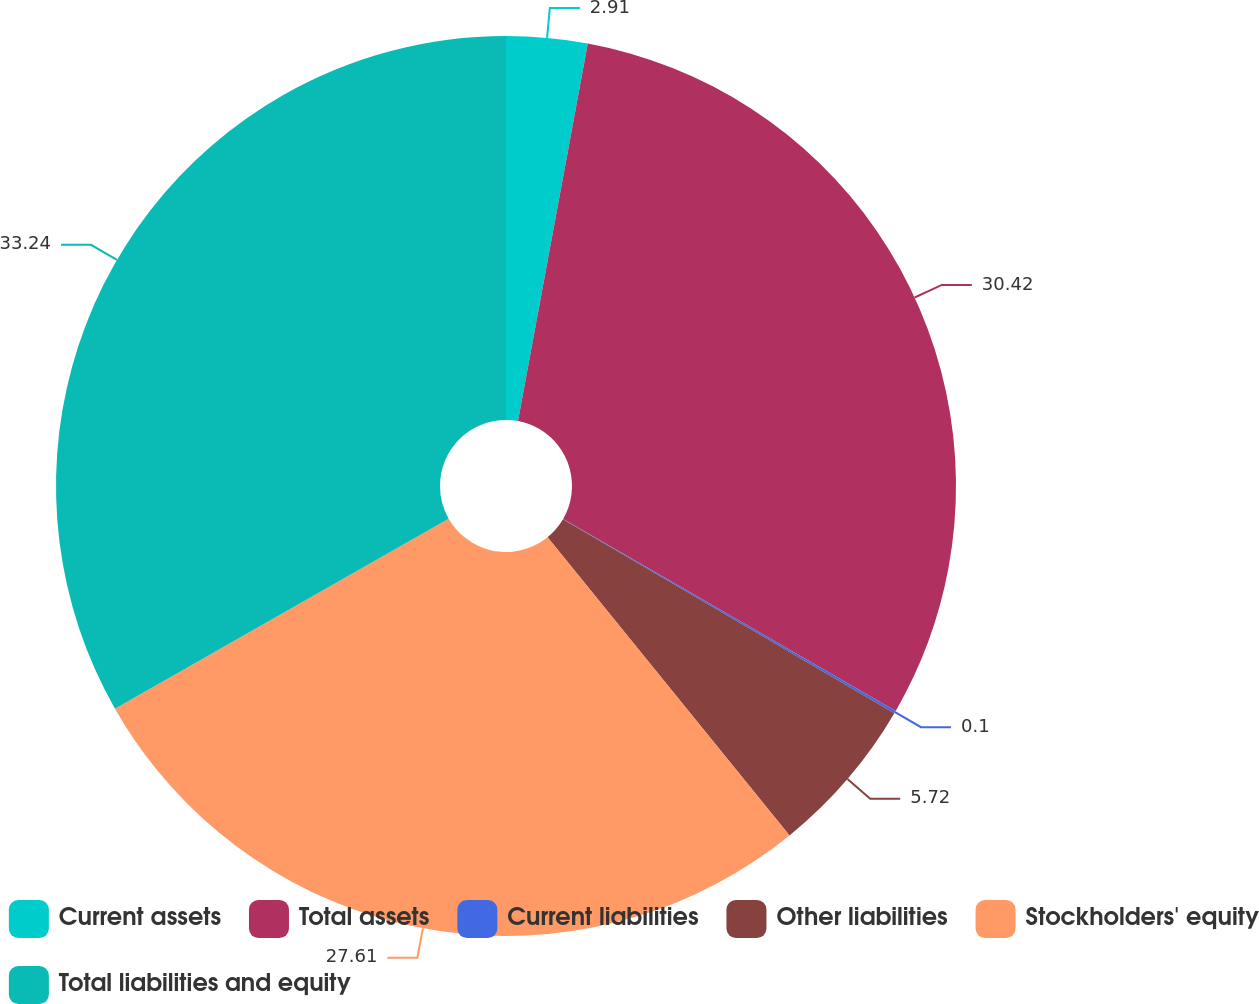Convert chart. <chart><loc_0><loc_0><loc_500><loc_500><pie_chart><fcel>Current assets<fcel>Total assets<fcel>Current liabilities<fcel>Other liabilities<fcel>Stockholders' equity<fcel>Total liabilities and equity<nl><fcel>2.91%<fcel>30.42%<fcel>0.1%<fcel>5.72%<fcel>27.61%<fcel>33.24%<nl></chart> 